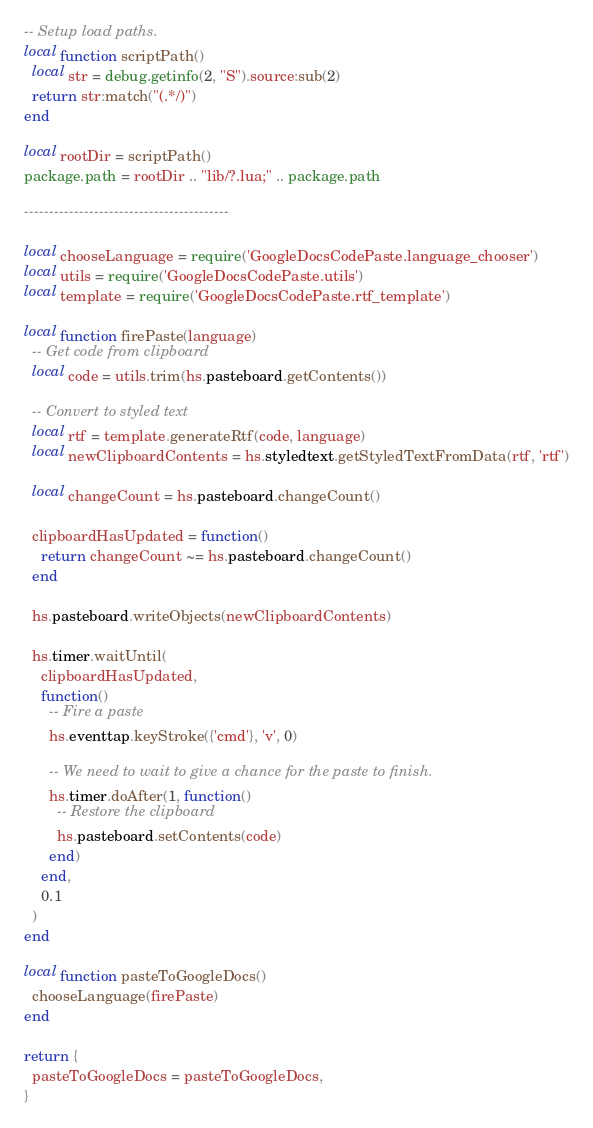<code> <loc_0><loc_0><loc_500><loc_500><_Lua_>-- Setup load paths.
local function scriptPath()
  local str = debug.getinfo(2, "S").source:sub(2)
  return str:match("(.*/)")
end

local rootDir = scriptPath()
package.path = rootDir .. "lib/?.lua;" .. package.path

-----------------------------------------

local chooseLanguage = require('GoogleDocsCodePaste.language_chooser')
local utils = require('GoogleDocsCodePaste.utils')
local template = require('GoogleDocsCodePaste.rtf_template')

local function firePaste(language)
  -- Get code from clipboard
  local code = utils.trim(hs.pasteboard.getContents())

  -- Convert to styled text
  local rtf = template.generateRtf(code, language)
  local newClipboardContents = hs.styledtext.getStyledTextFromData(rtf, 'rtf')

  local changeCount = hs.pasteboard.changeCount()

  clipboardHasUpdated = function()
    return changeCount ~= hs.pasteboard.changeCount()
  end

  hs.pasteboard.writeObjects(newClipboardContents)

  hs.timer.waitUntil(
    clipboardHasUpdated,
    function()
      -- Fire a paste
      hs.eventtap.keyStroke({'cmd'}, 'v', 0)

      -- We need to wait to give a chance for the paste to finish.
      hs.timer.doAfter(1, function()
        -- Restore the clipboard
        hs.pasteboard.setContents(code)
      end)
    end,
    0.1
  )
end

local function pasteToGoogleDocs()
  chooseLanguage(firePaste)
end

return {
  pasteToGoogleDocs = pasteToGoogleDocs,
}
</code> 